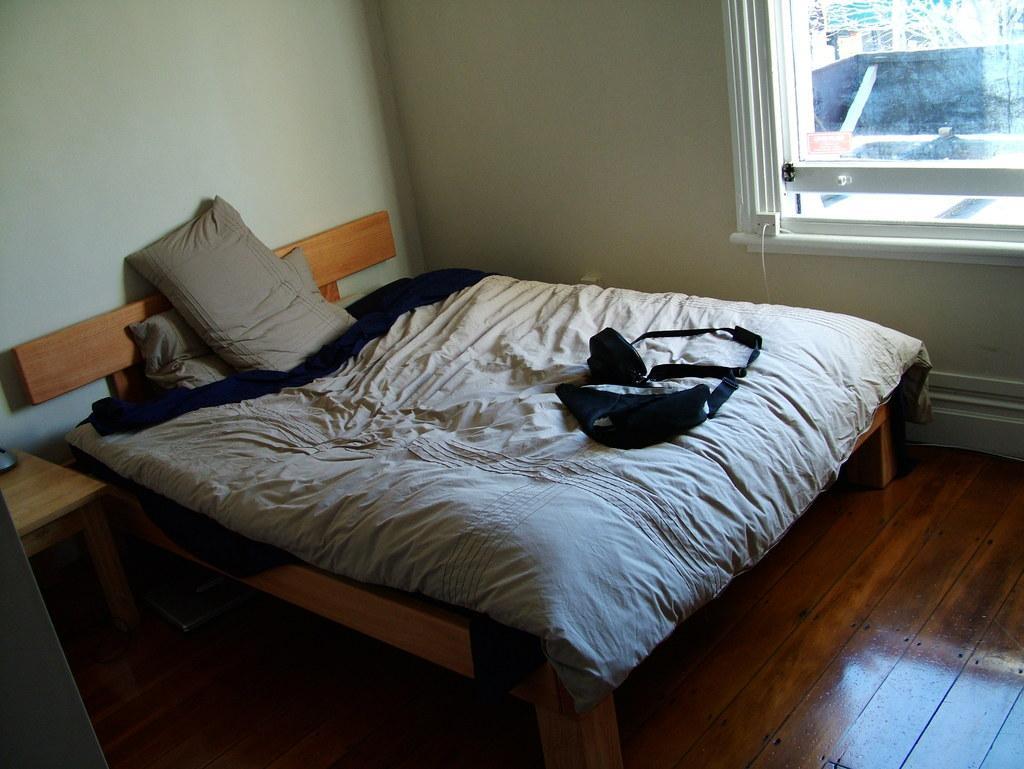In one or two sentences, can you explain what this image depicts? In this image I can see a bed and to the right there is a window. 